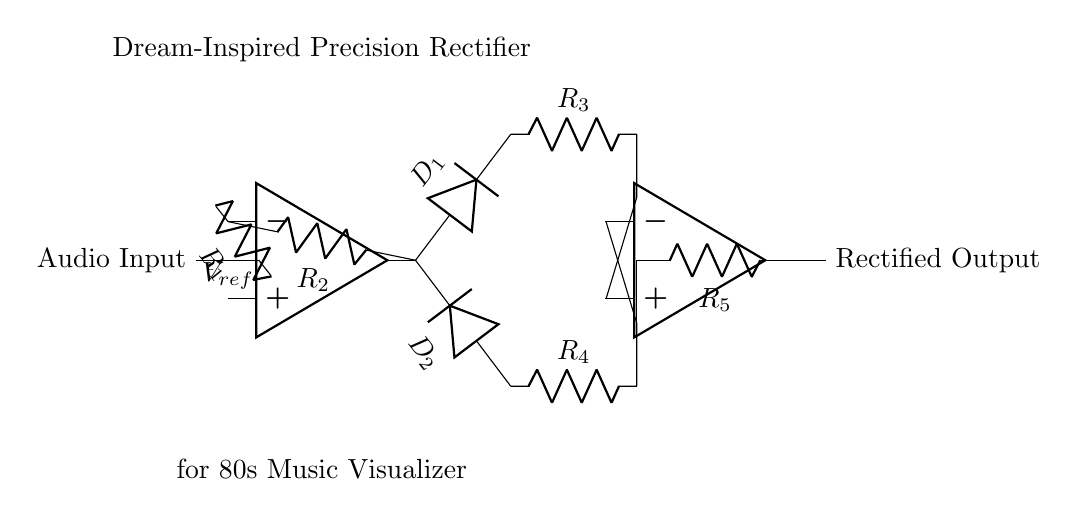What is the role of the operational amplifiers in this rectifier circuit? Operational amplifiers are key components that amplify the audio signal while allowing for precision rectification by controlling the paths of the input signals through feedback and diode arrangements.
Answer: Signal amplification What type of diodes are used in this circuit? The diagram features two diodes labeled D1 and D2, which facilitate the rectification process by allowing current to flow in only one direction.
Answer: Standard diodes What is the function of resistor R1? Resistor R1 is connected to the negative terminal of the first operational amplifier and serves as part of the current-limiting network, influencing the gain and processing of the audio signal entering the circuit.
Answer: Current limiter How many resistors are present in the circuit? There are five resistors (R1, R2, R3, R4, and R5) in total, positioned to interconnect the operational amplifiers and diodes for effective rectifier function.
Answer: Five Why does the circuit include a reference voltage (Vref)? Vref is vital in precision rectifiers, providing a stable reference that helps in accurately controlling the output signal, improving rectification performance, especially with small AC signals like audio.
Answer: To stabilize output What is the purpose of the feedback loop in this circuit? The feedback loop connects the output of the operational amplifiers back to their inputs, which is necessary for setting the gain of the amplifiers and ensuring that the circuit responds accurately to the input audio signal.
Answer: Gain control What does the output of this circuit represent? The output, labeled as Rectified Output, signifies that the audio signal has been processed to remove negative portions, allowing only the positive halves of the waveform to pass, essential for audio signal visualization.
Answer: Rectified audio signal 